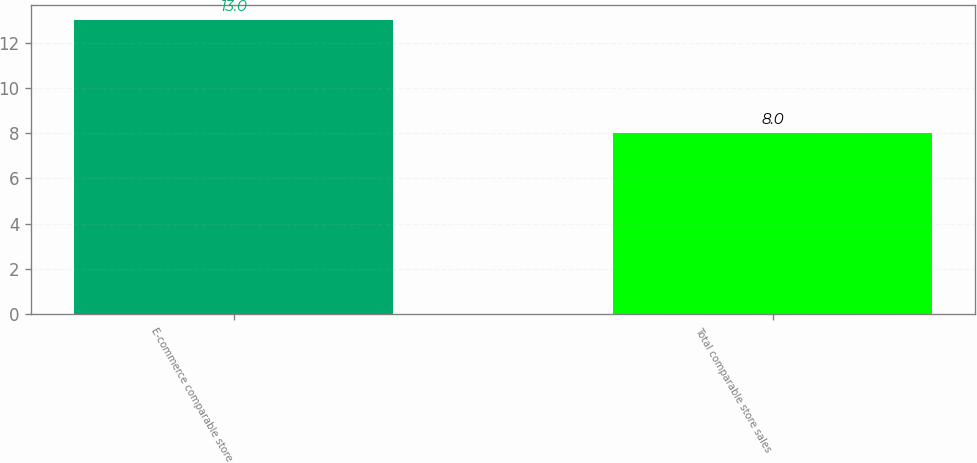Convert chart. <chart><loc_0><loc_0><loc_500><loc_500><bar_chart><fcel>E-commerce comparable store<fcel>Total comparable store sales<nl><fcel>13<fcel>8<nl></chart> 